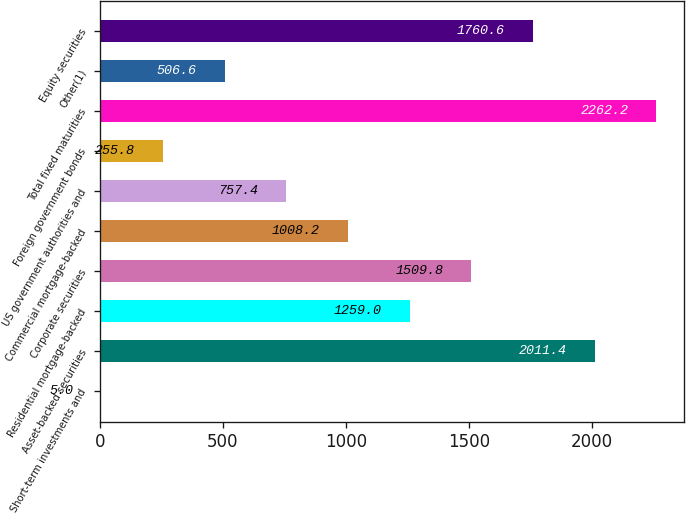Convert chart to OTSL. <chart><loc_0><loc_0><loc_500><loc_500><bar_chart><fcel>Short-term investments and<fcel>Asset-backed securities<fcel>Residential mortgage-backed<fcel>Corporate securities<fcel>Commercial mortgage-backed<fcel>US government authorities and<fcel>Foreign government bonds<fcel>Total fixed maturities<fcel>Other(1)<fcel>Equity securities<nl><fcel>5<fcel>2011.4<fcel>1259<fcel>1509.8<fcel>1008.2<fcel>757.4<fcel>255.8<fcel>2262.2<fcel>506.6<fcel>1760.6<nl></chart> 